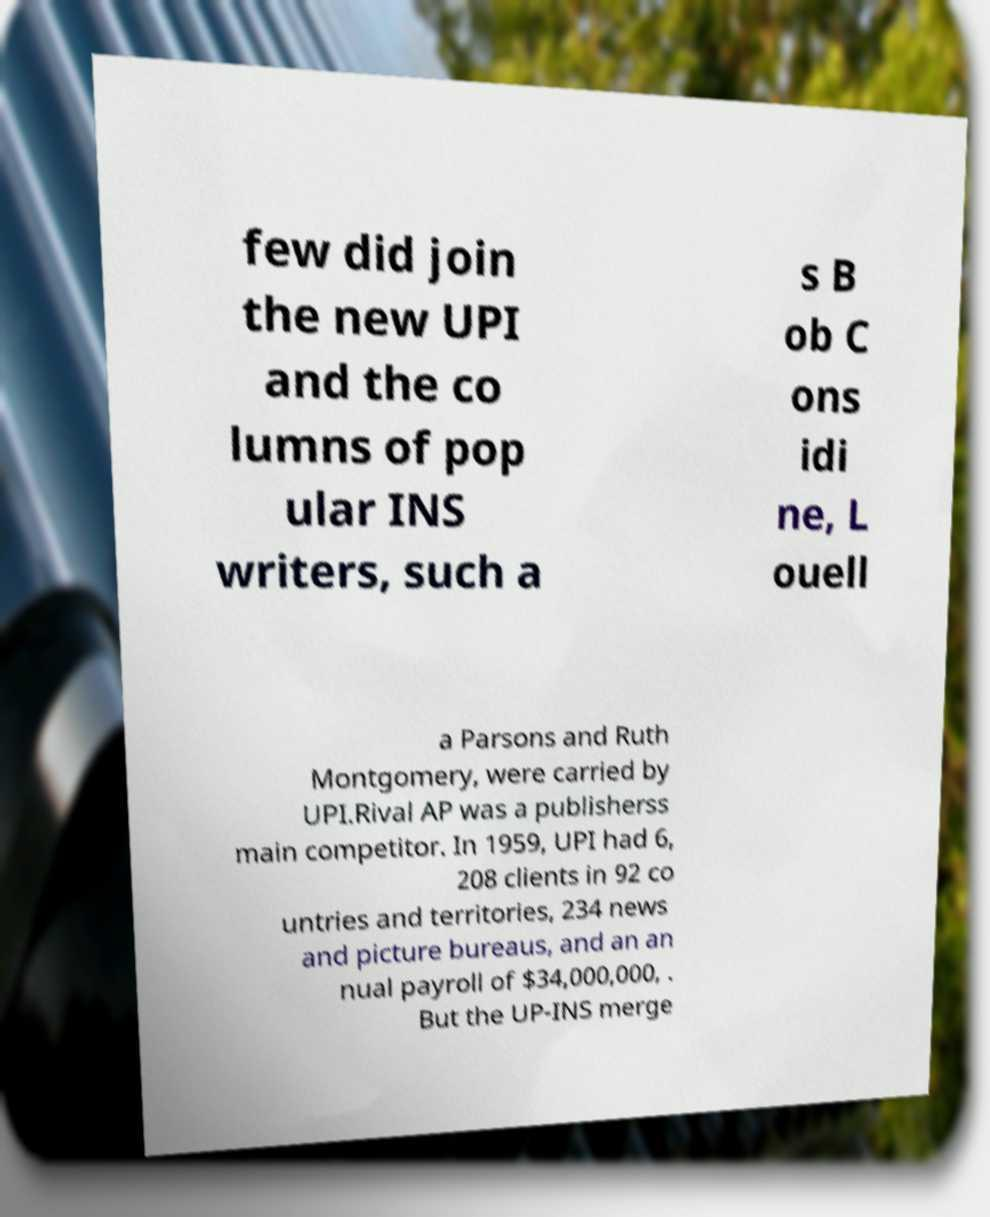There's text embedded in this image that I need extracted. Can you transcribe it verbatim? few did join the new UPI and the co lumns of pop ular INS writers, such a s B ob C ons idi ne, L ouell a Parsons and Ruth Montgomery, were carried by UPI.Rival AP was a publisherss main competitor. In 1959, UPI had 6, 208 clients in 92 co untries and territories, 234 news and picture bureaus, and an an nual payroll of $34,000,000, . But the UP-INS merge 